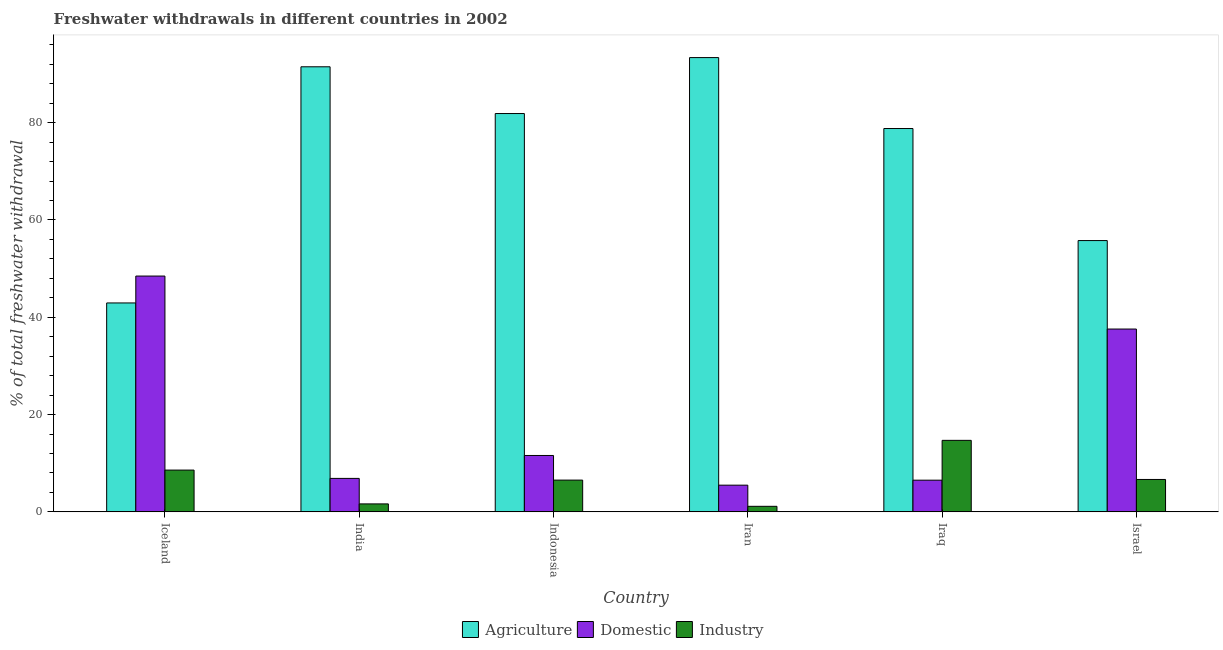How many different coloured bars are there?
Provide a short and direct response. 3. Are the number of bars per tick equal to the number of legend labels?
Offer a terse response. Yes. Are the number of bars on each tick of the X-axis equal?
Make the answer very short. Yes. How many bars are there on the 3rd tick from the left?
Give a very brief answer. 3. What is the label of the 4th group of bars from the left?
Keep it short and to the point. Iran. What is the percentage of freshwater withdrawal for agriculture in Indonesia?
Offer a terse response. 81.87. Across all countries, what is the maximum percentage of freshwater withdrawal for industry?
Offer a terse response. 14.7. Across all countries, what is the minimum percentage of freshwater withdrawal for domestic purposes?
Provide a short and direct response. 5.49. In which country was the percentage of freshwater withdrawal for industry maximum?
Ensure brevity in your answer.  Iraq. In which country was the percentage of freshwater withdrawal for industry minimum?
Ensure brevity in your answer.  Iran. What is the total percentage of freshwater withdrawal for industry in the graph?
Offer a terse response. 39.26. What is the difference between the percentage of freshwater withdrawal for domestic purposes in Iceland and that in Iran?
Provide a succinct answer. 42.98. What is the difference between the percentage of freshwater withdrawal for agriculture in Indonesia and the percentage of freshwater withdrawal for industry in Iceland?
Your answer should be compact. 73.28. What is the average percentage of freshwater withdrawal for industry per country?
Your response must be concise. 6.54. What is the difference between the percentage of freshwater withdrawal for agriculture and percentage of freshwater withdrawal for domestic purposes in Indonesia?
Give a very brief answer. 70.28. What is the ratio of the percentage of freshwater withdrawal for agriculture in India to that in Indonesia?
Your response must be concise. 1.12. What is the difference between the highest and the second highest percentage of freshwater withdrawal for domestic purposes?
Your answer should be compact. 10.89. What is the difference between the highest and the lowest percentage of freshwater withdrawal for domestic purposes?
Provide a succinct answer. 42.98. Is the sum of the percentage of freshwater withdrawal for domestic purposes in Iraq and Israel greater than the maximum percentage of freshwater withdrawal for agriculture across all countries?
Your answer should be very brief. No. What does the 3rd bar from the left in India represents?
Your response must be concise. Industry. What does the 3rd bar from the right in Iraq represents?
Ensure brevity in your answer.  Agriculture. Are all the bars in the graph horizontal?
Your response must be concise. No. Does the graph contain any zero values?
Provide a succinct answer. No. Does the graph contain grids?
Offer a terse response. No. Where does the legend appear in the graph?
Give a very brief answer. Bottom center. How many legend labels are there?
Offer a very short reply. 3. How are the legend labels stacked?
Provide a short and direct response. Horizontal. What is the title of the graph?
Offer a terse response. Freshwater withdrawals in different countries in 2002. Does "Ages 20-50" appear as one of the legend labels in the graph?
Ensure brevity in your answer.  No. What is the label or title of the X-axis?
Your answer should be very brief. Country. What is the label or title of the Y-axis?
Your answer should be compact. % of total freshwater withdrawal. What is the % of total freshwater withdrawal of Agriculture in Iceland?
Provide a short and direct response. 42.94. What is the % of total freshwater withdrawal of Domestic in Iceland?
Make the answer very short. 48.47. What is the % of total freshwater withdrawal of Industry in Iceland?
Keep it short and to the point. 8.59. What is the % of total freshwater withdrawal of Agriculture in India?
Provide a short and direct response. 91.48. What is the % of total freshwater withdrawal in Domestic in India?
Keep it short and to the point. 6.88. What is the % of total freshwater withdrawal of Industry in India?
Offer a terse response. 1.64. What is the % of total freshwater withdrawal of Agriculture in Indonesia?
Your response must be concise. 81.87. What is the % of total freshwater withdrawal in Domestic in Indonesia?
Ensure brevity in your answer.  11.59. What is the % of total freshwater withdrawal of Industry in Indonesia?
Give a very brief answer. 6.53. What is the % of total freshwater withdrawal in Agriculture in Iran?
Give a very brief answer. 93.37. What is the % of total freshwater withdrawal in Domestic in Iran?
Your answer should be very brief. 5.49. What is the % of total freshwater withdrawal in Industry in Iran?
Your response must be concise. 1.14. What is the % of total freshwater withdrawal in Agriculture in Iraq?
Keep it short and to the point. 78.79. What is the % of total freshwater withdrawal in Domestic in Iraq?
Your answer should be very brief. 6.51. What is the % of total freshwater withdrawal of Industry in Iraq?
Ensure brevity in your answer.  14.7. What is the % of total freshwater withdrawal in Agriculture in Israel?
Provide a short and direct response. 55.76. What is the % of total freshwater withdrawal of Domestic in Israel?
Keep it short and to the point. 37.58. What is the % of total freshwater withdrawal of Industry in Israel?
Give a very brief answer. 6.66. Across all countries, what is the maximum % of total freshwater withdrawal of Agriculture?
Your answer should be compact. 93.37. Across all countries, what is the maximum % of total freshwater withdrawal of Domestic?
Offer a very short reply. 48.47. Across all countries, what is the maximum % of total freshwater withdrawal of Industry?
Your answer should be compact. 14.7. Across all countries, what is the minimum % of total freshwater withdrawal in Agriculture?
Offer a terse response. 42.94. Across all countries, what is the minimum % of total freshwater withdrawal in Domestic?
Ensure brevity in your answer.  5.49. Across all countries, what is the minimum % of total freshwater withdrawal in Industry?
Make the answer very short. 1.14. What is the total % of total freshwater withdrawal in Agriculture in the graph?
Ensure brevity in your answer.  444.21. What is the total % of total freshwater withdrawal in Domestic in the graph?
Your answer should be very brief. 116.53. What is the total % of total freshwater withdrawal in Industry in the graph?
Provide a succinct answer. 39.26. What is the difference between the % of total freshwater withdrawal in Agriculture in Iceland and that in India?
Offer a very short reply. -48.54. What is the difference between the % of total freshwater withdrawal in Domestic in Iceland and that in India?
Ensure brevity in your answer.  41.59. What is the difference between the % of total freshwater withdrawal of Industry in Iceland and that in India?
Provide a short and direct response. 6.95. What is the difference between the % of total freshwater withdrawal of Agriculture in Iceland and that in Indonesia?
Give a very brief answer. -38.93. What is the difference between the % of total freshwater withdrawal of Domestic in Iceland and that in Indonesia?
Your response must be concise. 36.88. What is the difference between the % of total freshwater withdrawal in Industry in Iceland and that in Indonesia?
Your response must be concise. 2.06. What is the difference between the % of total freshwater withdrawal in Agriculture in Iceland and that in Iran?
Keep it short and to the point. -50.43. What is the difference between the % of total freshwater withdrawal in Domestic in Iceland and that in Iran?
Make the answer very short. 42.98. What is the difference between the % of total freshwater withdrawal of Industry in Iceland and that in Iran?
Give a very brief answer. 7.45. What is the difference between the % of total freshwater withdrawal in Agriculture in Iceland and that in Iraq?
Your response must be concise. -35.85. What is the difference between the % of total freshwater withdrawal of Domestic in Iceland and that in Iraq?
Ensure brevity in your answer.  41.95. What is the difference between the % of total freshwater withdrawal in Industry in Iceland and that in Iraq?
Give a very brief answer. -6.11. What is the difference between the % of total freshwater withdrawal of Agriculture in Iceland and that in Israel?
Your answer should be compact. -12.82. What is the difference between the % of total freshwater withdrawal in Domestic in Iceland and that in Israel?
Make the answer very short. 10.89. What is the difference between the % of total freshwater withdrawal of Industry in Iceland and that in Israel?
Make the answer very short. 1.93. What is the difference between the % of total freshwater withdrawal in Agriculture in India and that in Indonesia?
Keep it short and to the point. 9.61. What is the difference between the % of total freshwater withdrawal in Domestic in India and that in Indonesia?
Ensure brevity in your answer.  -4.71. What is the difference between the % of total freshwater withdrawal of Industry in India and that in Indonesia?
Your answer should be compact. -4.89. What is the difference between the % of total freshwater withdrawal in Agriculture in India and that in Iran?
Offer a terse response. -1.89. What is the difference between the % of total freshwater withdrawal of Domestic in India and that in Iran?
Offer a very short reply. 1.39. What is the difference between the % of total freshwater withdrawal in Industry in India and that in Iran?
Provide a succinct answer. 0.49. What is the difference between the % of total freshwater withdrawal in Agriculture in India and that in Iraq?
Your answer should be very brief. 12.69. What is the difference between the % of total freshwater withdrawal of Domestic in India and that in Iraq?
Your response must be concise. 0.37. What is the difference between the % of total freshwater withdrawal in Industry in India and that in Iraq?
Give a very brief answer. -13.06. What is the difference between the % of total freshwater withdrawal of Agriculture in India and that in Israel?
Make the answer very short. 35.72. What is the difference between the % of total freshwater withdrawal of Domestic in India and that in Israel?
Ensure brevity in your answer.  -30.7. What is the difference between the % of total freshwater withdrawal of Industry in India and that in Israel?
Your answer should be compact. -5.03. What is the difference between the % of total freshwater withdrawal of Agriculture in Indonesia and that in Iran?
Ensure brevity in your answer.  -11.5. What is the difference between the % of total freshwater withdrawal in Domestic in Indonesia and that in Iran?
Your answer should be very brief. 6.1. What is the difference between the % of total freshwater withdrawal in Industry in Indonesia and that in Iran?
Give a very brief answer. 5.39. What is the difference between the % of total freshwater withdrawal of Agriculture in Indonesia and that in Iraq?
Make the answer very short. 3.08. What is the difference between the % of total freshwater withdrawal of Domestic in Indonesia and that in Iraq?
Keep it short and to the point. 5.08. What is the difference between the % of total freshwater withdrawal of Industry in Indonesia and that in Iraq?
Give a very brief answer. -8.17. What is the difference between the % of total freshwater withdrawal of Agriculture in Indonesia and that in Israel?
Ensure brevity in your answer.  26.11. What is the difference between the % of total freshwater withdrawal of Domestic in Indonesia and that in Israel?
Offer a very short reply. -25.99. What is the difference between the % of total freshwater withdrawal in Industry in Indonesia and that in Israel?
Provide a succinct answer. -0.13. What is the difference between the % of total freshwater withdrawal in Agriculture in Iran and that in Iraq?
Make the answer very short. 14.58. What is the difference between the % of total freshwater withdrawal in Domestic in Iran and that in Iraq?
Ensure brevity in your answer.  -1.02. What is the difference between the % of total freshwater withdrawal of Industry in Iran and that in Iraq?
Your answer should be compact. -13.56. What is the difference between the % of total freshwater withdrawal in Agriculture in Iran and that in Israel?
Keep it short and to the point. 37.61. What is the difference between the % of total freshwater withdrawal of Domestic in Iran and that in Israel?
Provide a short and direct response. -32.09. What is the difference between the % of total freshwater withdrawal of Industry in Iran and that in Israel?
Your response must be concise. -5.52. What is the difference between the % of total freshwater withdrawal in Agriculture in Iraq and that in Israel?
Offer a very short reply. 23.03. What is the difference between the % of total freshwater withdrawal of Domestic in Iraq and that in Israel?
Your response must be concise. -31.07. What is the difference between the % of total freshwater withdrawal in Industry in Iraq and that in Israel?
Your answer should be compact. 8.04. What is the difference between the % of total freshwater withdrawal in Agriculture in Iceland and the % of total freshwater withdrawal in Domestic in India?
Give a very brief answer. 36.06. What is the difference between the % of total freshwater withdrawal of Agriculture in Iceland and the % of total freshwater withdrawal of Industry in India?
Your response must be concise. 41.3. What is the difference between the % of total freshwater withdrawal in Domestic in Iceland and the % of total freshwater withdrawal in Industry in India?
Provide a succinct answer. 46.83. What is the difference between the % of total freshwater withdrawal in Agriculture in Iceland and the % of total freshwater withdrawal in Domestic in Indonesia?
Your answer should be very brief. 31.35. What is the difference between the % of total freshwater withdrawal of Agriculture in Iceland and the % of total freshwater withdrawal of Industry in Indonesia?
Your answer should be compact. 36.41. What is the difference between the % of total freshwater withdrawal in Domestic in Iceland and the % of total freshwater withdrawal in Industry in Indonesia?
Provide a short and direct response. 41.94. What is the difference between the % of total freshwater withdrawal in Agriculture in Iceland and the % of total freshwater withdrawal in Domestic in Iran?
Give a very brief answer. 37.45. What is the difference between the % of total freshwater withdrawal of Agriculture in Iceland and the % of total freshwater withdrawal of Industry in Iran?
Ensure brevity in your answer.  41.8. What is the difference between the % of total freshwater withdrawal in Domestic in Iceland and the % of total freshwater withdrawal in Industry in Iran?
Offer a terse response. 47.33. What is the difference between the % of total freshwater withdrawal in Agriculture in Iceland and the % of total freshwater withdrawal in Domestic in Iraq?
Provide a short and direct response. 36.42. What is the difference between the % of total freshwater withdrawal in Agriculture in Iceland and the % of total freshwater withdrawal in Industry in Iraq?
Your answer should be compact. 28.24. What is the difference between the % of total freshwater withdrawal in Domestic in Iceland and the % of total freshwater withdrawal in Industry in Iraq?
Your response must be concise. 33.77. What is the difference between the % of total freshwater withdrawal of Agriculture in Iceland and the % of total freshwater withdrawal of Domestic in Israel?
Offer a very short reply. 5.36. What is the difference between the % of total freshwater withdrawal in Agriculture in Iceland and the % of total freshwater withdrawal in Industry in Israel?
Your response must be concise. 36.28. What is the difference between the % of total freshwater withdrawal of Domestic in Iceland and the % of total freshwater withdrawal of Industry in Israel?
Offer a terse response. 41.81. What is the difference between the % of total freshwater withdrawal in Agriculture in India and the % of total freshwater withdrawal in Domestic in Indonesia?
Offer a terse response. 79.89. What is the difference between the % of total freshwater withdrawal in Agriculture in India and the % of total freshwater withdrawal in Industry in Indonesia?
Provide a short and direct response. 84.95. What is the difference between the % of total freshwater withdrawal of Domestic in India and the % of total freshwater withdrawal of Industry in Indonesia?
Offer a very short reply. 0.35. What is the difference between the % of total freshwater withdrawal of Agriculture in India and the % of total freshwater withdrawal of Domestic in Iran?
Your answer should be compact. 85.99. What is the difference between the % of total freshwater withdrawal in Agriculture in India and the % of total freshwater withdrawal in Industry in Iran?
Make the answer very short. 90.34. What is the difference between the % of total freshwater withdrawal in Domestic in India and the % of total freshwater withdrawal in Industry in Iran?
Your answer should be very brief. 5.74. What is the difference between the % of total freshwater withdrawal of Agriculture in India and the % of total freshwater withdrawal of Domestic in Iraq?
Provide a succinct answer. 84.97. What is the difference between the % of total freshwater withdrawal of Agriculture in India and the % of total freshwater withdrawal of Industry in Iraq?
Your answer should be compact. 76.78. What is the difference between the % of total freshwater withdrawal in Domestic in India and the % of total freshwater withdrawal in Industry in Iraq?
Provide a succinct answer. -7.82. What is the difference between the % of total freshwater withdrawal in Agriculture in India and the % of total freshwater withdrawal in Domestic in Israel?
Ensure brevity in your answer.  53.9. What is the difference between the % of total freshwater withdrawal in Agriculture in India and the % of total freshwater withdrawal in Industry in Israel?
Provide a succinct answer. 84.82. What is the difference between the % of total freshwater withdrawal of Domestic in India and the % of total freshwater withdrawal of Industry in Israel?
Provide a succinct answer. 0.22. What is the difference between the % of total freshwater withdrawal in Agriculture in Indonesia and the % of total freshwater withdrawal in Domestic in Iran?
Your response must be concise. 76.38. What is the difference between the % of total freshwater withdrawal in Agriculture in Indonesia and the % of total freshwater withdrawal in Industry in Iran?
Offer a very short reply. 80.73. What is the difference between the % of total freshwater withdrawal in Domestic in Indonesia and the % of total freshwater withdrawal in Industry in Iran?
Offer a terse response. 10.45. What is the difference between the % of total freshwater withdrawal of Agriculture in Indonesia and the % of total freshwater withdrawal of Domestic in Iraq?
Make the answer very short. 75.36. What is the difference between the % of total freshwater withdrawal of Agriculture in Indonesia and the % of total freshwater withdrawal of Industry in Iraq?
Ensure brevity in your answer.  67.17. What is the difference between the % of total freshwater withdrawal in Domestic in Indonesia and the % of total freshwater withdrawal in Industry in Iraq?
Give a very brief answer. -3.11. What is the difference between the % of total freshwater withdrawal of Agriculture in Indonesia and the % of total freshwater withdrawal of Domestic in Israel?
Make the answer very short. 44.29. What is the difference between the % of total freshwater withdrawal of Agriculture in Indonesia and the % of total freshwater withdrawal of Industry in Israel?
Give a very brief answer. 75.21. What is the difference between the % of total freshwater withdrawal of Domestic in Indonesia and the % of total freshwater withdrawal of Industry in Israel?
Your response must be concise. 4.93. What is the difference between the % of total freshwater withdrawal of Agriculture in Iran and the % of total freshwater withdrawal of Domestic in Iraq?
Give a very brief answer. 86.86. What is the difference between the % of total freshwater withdrawal in Agriculture in Iran and the % of total freshwater withdrawal in Industry in Iraq?
Your answer should be compact. 78.67. What is the difference between the % of total freshwater withdrawal in Domestic in Iran and the % of total freshwater withdrawal in Industry in Iraq?
Give a very brief answer. -9.21. What is the difference between the % of total freshwater withdrawal of Agriculture in Iran and the % of total freshwater withdrawal of Domestic in Israel?
Keep it short and to the point. 55.79. What is the difference between the % of total freshwater withdrawal of Agriculture in Iran and the % of total freshwater withdrawal of Industry in Israel?
Provide a succinct answer. 86.71. What is the difference between the % of total freshwater withdrawal in Domestic in Iran and the % of total freshwater withdrawal in Industry in Israel?
Ensure brevity in your answer.  -1.17. What is the difference between the % of total freshwater withdrawal of Agriculture in Iraq and the % of total freshwater withdrawal of Domestic in Israel?
Make the answer very short. 41.21. What is the difference between the % of total freshwater withdrawal in Agriculture in Iraq and the % of total freshwater withdrawal in Industry in Israel?
Ensure brevity in your answer.  72.13. What is the difference between the % of total freshwater withdrawal of Domestic in Iraq and the % of total freshwater withdrawal of Industry in Israel?
Your answer should be very brief. -0.15. What is the average % of total freshwater withdrawal of Agriculture per country?
Keep it short and to the point. 74.03. What is the average % of total freshwater withdrawal of Domestic per country?
Offer a terse response. 19.42. What is the average % of total freshwater withdrawal in Industry per country?
Keep it short and to the point. 6.54. What is the difference between the % of total freshwater withdrawal in Agriculture and % of total freshwater withdrawal in Domestic in Iceland?
Offer a terse response. -5.53. What is the difference between the % of total freshwater withdrawal in Agriculture and % of total freshwater withdrawal in Industry in Iceland?
Provide a short and direct response. 34.35. What is the difference between the % of total freshwater withdrawal in Domestic and % of total freshwater withdrawal in Industry in Iceland?
Ensure brevity in your answer.  39.88. What is the difference between the % of total freshwater withdrawal in Agriculture and % of total freshwater withdrawal in Domestic in India?
Offer a terse response. 84.6. What is the difference between the % of total freshwater withdrawal in Agriculture and % of total freshwater withdrawal in Industry in India?
Keep it short and to the point. 89.84. What is the difference between the % of total freshwater withdrawal of Domestic and % of total freshwater withdrawal of Industry in India?
Ensure brevity in your answer.  5.24. What is the difference between the % of total freshwater withdrawal of Agriculture and % of total freshwater withdrawal of Domestic in Indonesia?
Offer a very short reply. 70.28. What is the difference between the % of total freshwater withdrawal in Agriculture and % of total freshwater withdrawal in Industry in Indonesia?
Make the answer very short. 75.34. What is the difference between the % of total freshwater withdrawal in Domestic and % of total freshwater withdrawal in Industry in Indonesia?
Keep it short and to the point. 5.06. What is the difference between the % of total freshwater withdrawal in Agriculture and % of total freshwater withdrawal in Domestic in Iran?
Give a very brief answer. 87.88. What is the difference between the % of total freshwater withdrawal in Agriculture and % of total freshwater withdrawal in Industry in Iran?
Give a very brief answer. 92.23. What is the difference between the % of total freshwater withdrawal in Domestic and % of total freshwater withdrawal in Industry in Iran?
Your answer should be compact. 4.35. What is the difference between the % of total freshwater withdrawal of Agriculture and % of total freshwater withdrawal of Domestic in Iraq?
Keep it short and to the point. 72.28. What is the difference between the % of total freshwater withdrawal in Agriculture and % of total freshwater withdrawal in Industry in Iraq?
Provide a short and direct response. 64.09. What is the difference between the % of total freshwater withdrawal in Domestic and % of total freshwater withdrawal in Industry in Iraq?
Your answer should be compact. -8.19. What is the difference between the % of total freshwater withdrawal in Agriculture and % of total freshwater withdrawal in Domestic in Israel?
Provide a succinct answer. 18.18. What is the difference between the % of total freshwater withdrawal in Agriculture and % of total freshwater withdrawal in Industry in Israel?
Provide a short and direct response. 49.1. What is the difference between the % of total freshwater withdrawal of Domestic and % of total freshwater withdrawal of Industry in Israel?
Make the answer very short. 30.92. What is the ratio of the % of total freshwater withdrawal of Agriculture in Iceland to that in India?
Offer a terse response. 0.47. What is the ratio of the % of total freshwater withdrawal of Domestic in Iceland to that in India?
Provide a succinct answer. 7.04. What is the ratio of the % of total freshwater withdrawal in Industry in Iceland to that in India?
Offer a terse response. 5.24. What is the ratio of the % of total freshwater withdrawal of Agriculture in Iceland to that in Indonesia?
Your answer should be very brief. 0.52. What is the ratio of the % of total freshwater withdrawal in Domestic in Iceland to that in Indonesia?
Your answer should be compact. 4.18. What is the ratio of the % of total freshwater withdrawal in Industry in Iceland to that in Indonesia?
Your response must be concise. 1.32. What is the ratio of the % of total freshwater withdrawal of Agriculture in Iceland to that in Iran?
Make the answer very short. 0.46. What is the ratio of the % of total freshwater withdrawal in Domestic in Iceland to that in Iran?
Your answer should be very brief. 8.83. What is the ratio of the % of total freshwater withdrawal of Industry in Iceland to that in Iran?
Offer a terse response. 7.51. What is the ratio of the % of total freshwater withdrawal of Agriculture in Iceland to that in Iraq?
Offer a very short reply. 0.55. What is the ratio of the % of total freshwater withdrawal in Domestic in Iceland to that in Iraq?
Offer a very short reply. 7.44. What is the ratio of the % of total freshwater withdrawal of Industry in Iceland to that in Iraq?
Offer a very short reply. 0.58. What is the ratio of the % of total freshwater withdrawal in Agriculture in Iceland to that in Israel?
Provide a short and direct response. 0.77. What is the ratio of the % of total freshwater withdrawal of Domestic in Iceland to that in Israel?
Your answer should be very brief. 1.29. What is the ratio of the % of total freshwater withdrawal in Industry in Iceland to that in Israel?
Give a very brief answer. 1.29. What is the ratio of the % of total freshwater withdrawal of Agriculture in India to that in Indonesia?
Offer a very short reply. 1.12. What is the ratio of the % of total freshwater withdrawal in Domestic in India to that in Indonesia?
Provide a succinct answer. 0.59. What is the ratio of the % of total freshwater withdrawal in Industry in India to that in Indonesia?
Ensure brevity in your answer.  0.25. What is the ratio of the % of total freshwater withdrawal of Agriculture in India to that in Iran?
Give a very brief answer. 0.98. What is the ratio of the % of total freshwater withdrawal of Domestic in India to that in Iran?
Make the answer very short. 1.25. What is the ratio of the % of total freshwater withdrawal in Industry in India to that in Iran?
Offer a very short reply. 1.43. What is the ratio of the % of total freshwater withdrawal of Agriculture in India to that in Iraq?
Give a very brief answer. 1.16. What is the ratio of the % of total freshwater withdrawal in Domestic in India to that in Iraq?
Ensure brevity in your answer.  1.06. What is the ratio of the % of total freshwater withdrawal in Industry in India to that in Iraq?
Give a very brief answer. 0.11. What is the ratio of the % of total freshwater withdrawal of Agriculture in India to that in Israel?
Your response must be concise. 1.64. What is the ratio of the % of total freshwater withdrawal in Domestic in India to that in Israel?
Provide a succinct answer. 0.18. What is the ratio of the % of total freshwater withdrawal of Industry in India to that in Israel?
Provide a succinct answer. 0.25. What is the ratio of the % of total freshwater withdrawal in Agriculture in Indonesia to that in Iran?
Offer a terse response. 0.88. What is the ratio of the % of total freshwater withdrawal of Domestic in Indonesia to that in Iran?
Offer a very short reply. 2.11. What is the ratio of the % of total freshwater withdrawal in Industry in Indonesia to that in Iran?
Keep it short and to the point. 5.71. What is the ratio of the % of total freshwater withdrawal in Agriculture in Indonesia to that in Iraq?
Your response must be concise. 1.04. What is the ratio of the % of total freshwater withdrawal of Domestic in Indonesia to that in Iraq?
Keep it short and to the point. 1.78. What is the ratio of the % of total freshwater withdrawal in Industry in Indonesia to that in Iraq?
Offer a terse response. 0.44. What is the ratio of the % of total freshwater withdrawal of Agriculture in Indonesia to that in Israel?
Provide a succinct answer. 1.47. What is the ratio of the % of total freshwater withdrawal in Domestic in Indonesia to that in Israel?
Ensure brevity in your answer.  0.31. What is the ratio of the % of total freshwater withdrawal of Agriculture in Iran to that in Iraq?
Give a very brief answer. 1.19. What is the ratio of the % of total freshwater withdrawal in Domestic in Iran to that in Iraq?
Your answer should be very brief. 0.84. What is the ratio of the % of total freshwater withdrawal in Industry in Iran to that in Iraq?
Provide a succinct answer. 0.08. What is the ratio of the % of total freshwater withdrawal of Agriculture in Iran to that in Israel?
Ensure brevity in your answer.  1.67. What is the ratio of the % of total freshwater withdrawal in Domestic in Iran to that in Israel?
Provide a short and direct response. 0.15. What is the ratio of the % of total freshwater withdrawal in Industry in Iran to that in Israel?
Give a very brief answer. 0.17. What is the ratio of the % of total freshwater withdrawal in Agriculture in Iraq to that in Israel?
Give a very brief answer. 1.41. What is the ratio of the % of total freshwater withdrawal in Domestic in Iraq to that in Israel?
Ensure brevity in your answer.  0.17. What is the ratio of the % of total freshwater withdrawal in Industry in Iraq to that in Israel?
Provide a succinct answer. 2.21. What is the difference between the highest and the second highest % of total freshwater withdrawal in Agriculture?
Provide a succinct answer. 1.89. What is the difference between the highest and the second highest % of total freshwater withdrawal of Domestic?
Your response must be concise. 10.89. What is the difference between the highest and the second highest % of total freshwater withdrawal of Industry?
Your response must be concise. 6.11. What is the difference between the highest and the lowest % of total freshwater withdrawal in Agriculture?
Your answer should be compact. 50.43. What is the difference between the highest and the lowest % of total freshwater withdrawal in Domestic?
Offer a terse response. 42.98. What is the difference between the highest and the lowest % of total freshwater withdrawal in Industry?
Offer a terse response. 13.56. 